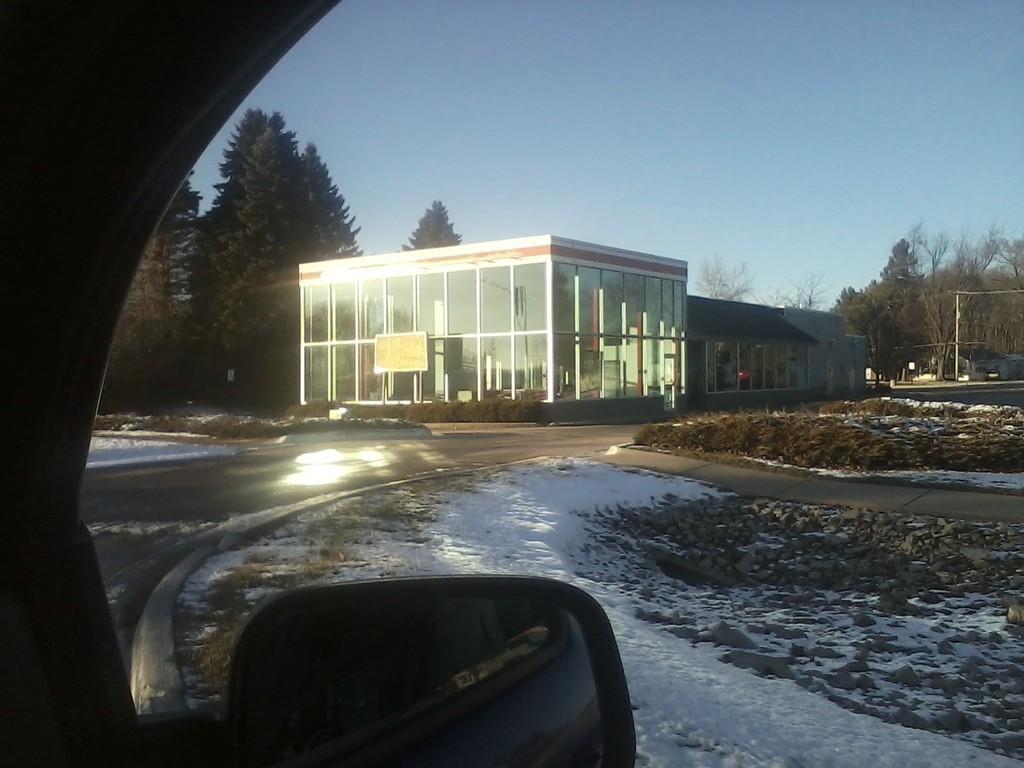Could you give a brief overview of what you see in this image? In this image I can see the picture from inside of the car. I can see the side mirror, the road, some snow on the ground, some grass, few poles, few trees and a building which is made up of glass. 